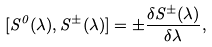Convert formula to latex. <formula><loc_0><loc_0><loc_500><loc_500>[ S ^ { 0 } ( \lambda ) , S ^ { \pm } ( \lambda ) ] = \pm \frac { \delta S ^ { \pm } ( \lambda ) } { \delta \lambda } ,</formula> 